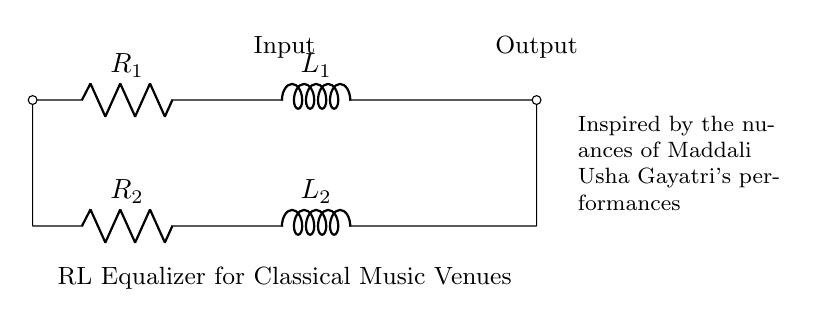What are the components in the circuit? The components in this circuit are two resistors and two inductors, as indicated in the diagram with their respective labels R1, L1, R2, and L2.
Answer: Two resistors and two inductors What is the purpose of this circuit? The circuit serves as an equalizer for classical music venues, allowing for adjustments in sound frequencies to enhance the listening experience.
Answer: Equalizer for classical music How many resistors are present in the circuit? The diagram shows two resistors labeled R1 and R2, clearly marked in the circuit layout.
Answer: Two What is the function of the inductor in this circuit? The inductor in the circuit is used to store energy in a magnetic field, and it can influence the frequency response of the circuit, affecting sound quality and equalization.
Answer: Store energy Which component would affect the circuit primarily at low frequencies? The inductor L1 and L2 play a significant role in controlling current flow and impedance at low frequencies, thus primarily affecting them in this equalizer circuit.
Answer: Inductors What is the relationship between R1 and L1 in this circuit? Resistor R1 is in series with inductor L1; thus, the combination affects the circuit's overall impedance and response to different frequencies.
Answer: Series connection How does the circuit influence the output sound quality? The combination of resistors and inductors in this RL circuit equalizes sound by modifying the frequency response, enhancing certain tones while suppressing others based on their impedance characteristics.
Answer: Modifies frequency response 